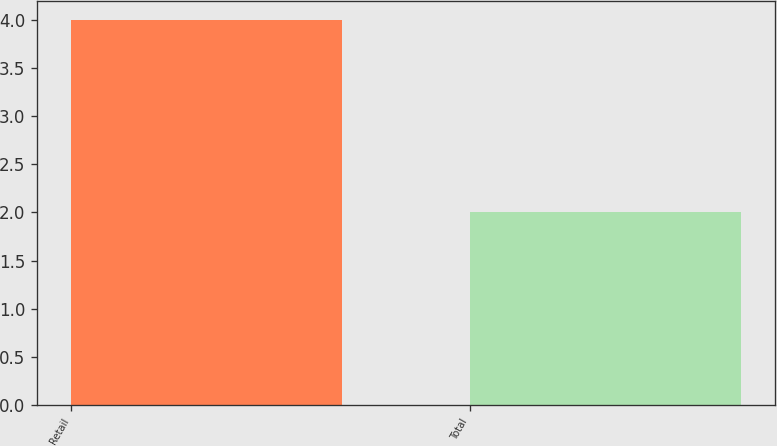<chart> <loc_0><loc_0><loc_500><loc_500><bar_chart><fcel>Retail<fcel>Total<nl><fcel>4<fcel>2<nl></chart> 